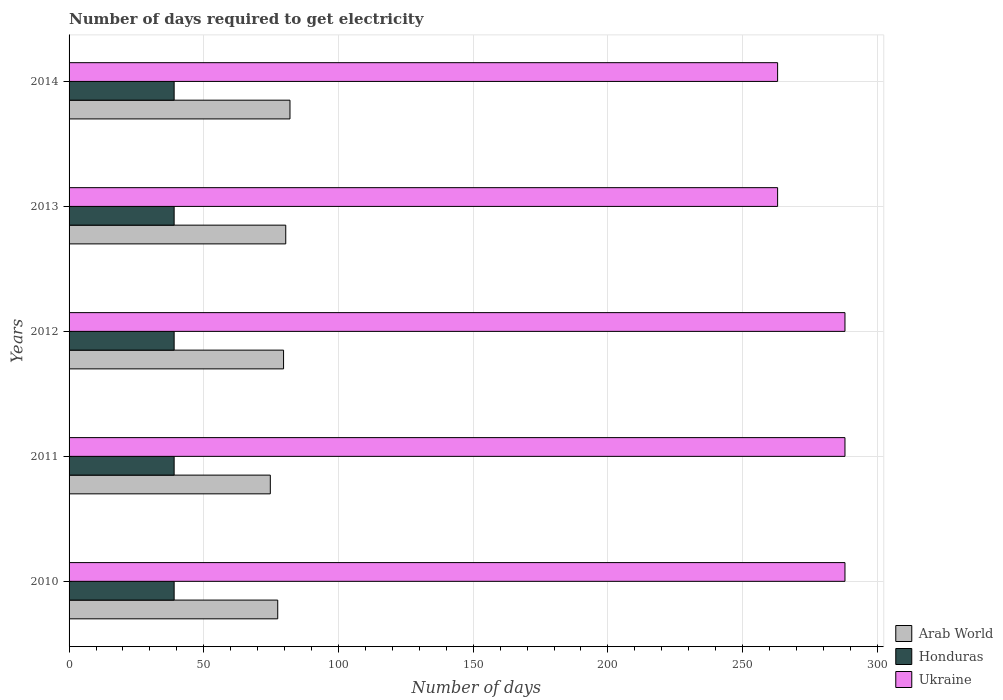Are the number of bars on each tick of the Y-axis equal?
Give a very brief answer. Yes. How many bars are there on the 2nd tick from the top?
Offer a terse response. 3. How many bars are there on the 1st tick from the bottom?
Your response must be concise. 3. What is the label of the 5th group of bars from the top?
Provide a short and direct response. 2010. What is the number of days required to get electricity in in Arab World in 2010?
Offer a terse response. 77.45. Across all years, what is the maximum number of days required to get electricity in in Ukraine?
Make the answer very short. 288. Across all years, what is the minimum number of days required to get electricity in in Honduras?
Ensure brevity in your answer.  39. What is the total number of days required to get electricity in in Ukraine in the graph?
Your answer should be very brief. 1390. What is the difference between the number of days required to get electricity in in Ukraine in 2011 and that in 2014?
Offer a very short reply. 25. What is the difference between the number of days required to get electricity in in Ukraine in 2010 and the number of days required to get electricity in in Honduras in 2012?
Make the answer very short. 249. What is the average number of days required to get electricity in in Ukraine per year?
Provide a short and direct response. 278. In the year 2012, what is the difference between the number of days required to get electricity in in Honduras and number of days required to get electricity in in Ukraine?
Keep it short and to the point. -249. What is the ratio of the number of days required to get electricity in in Arab World in 2011 to that in 2012?
Provide a short and direct response. 0.94. Is the number of days required to get electricity in in Ukraine in 2011 less than that in 2014?
Ensure brevity in your answer.  No. Is the difference between the number of days required to get electricity in in Honduras in 2011 and 2013 greater than the difference between the number of days required to get electricity in in Ukraine in 2011 and 2013?
Ensure brevity in your answer.  No. What is the difference between the highest and the second highest number of days required to get electricity in in Arab World?
Your answer should be very brief. 1.57. What is the difference between the highest and the lowest number of days required to get electricity in in Honduras?
Make the answer very short. 0. What does the 2nd bar from the top in 2011 represents?
Offer a very short reply. Honduras. What does the 2nd bar from the bottom in 2013 represents?
Keep it short and to the point. Honduras. How many bars are there?
Provide a short and direct response. 15. Are all the bars in the graph horizontal?
Your answer should be very brief. Yes. How many years are there in the graph?
Keep it short and to the point. 5. What is the difference between two consecutive major ticks on the X-axis?
Offer a very short reply. 50. Does the graph contain any zero values?
Keep it short and to the point. No. Where does the legend appear in the graph?
Offer a very short reply. Bottom right. How many legend labels are there?
Offer a very short reply. 3. How are the legend labels stacked?
Your answer should be very brief. Vertical. What is the title of the graph?
Give a very brief answer. Number of days required to get electricity. What is the label or title of the X-axis?
Make the answer very short. Number of days. What is the Number of days in Arab World in 2010?
Offer a terse response. 77.45. What is the Number of days of Ukraine in 2010?
Ensure brevity in your answer.  288. What is the Number of days of Arab World in 2011?
Your answer should be very brief. 74.7. What is the Number of days of Honduras in 2011?
Give a very brief answer. 39. What is the Number of days of Ukraine in 2011?
Offer a terse response. 288. What is the Number of days in Arab World in 2012?
Give a very brief answer. 79.62. What is the Number of days of Honduras in 2012?
Your answer should be compact. 39. What is the Number of days of Ukraine in 2012?
Provide a short and direct response. 288. What is the Number of days in Arab World in 2013?
Provide a succinct answer. 80.43. What is the Number of days of Honduras in 2013?
Provide a succinct answer. 39. What is the Number of days in Ukraine in 2013?
Your response must be concise. 263. What is the Number of days of Honduras in 2014?
Keep it short and to the point. 39. What is the Number of days in Ukraine in 2014?
Your answer should be very brief. 263. Across all years, what is the maximum Number of days in Honduras?
Provide a succinct answer. 39. Across all years, what is the maximum Number of days in Ukraine?
Give a very brief answer. 288. Across all years, what is the minimum Number of days of Arab World?
Ensure brevity in your answer.  74.7. Across all years, what is the minimum Number of days of Ukraine?
Make the answer very short. 263. What is the total Number of days of Arab World in the graph?
Provide a succinct answer. 394.2. What is the total Number of days in Honduras in the graph?
Your response must be concise. 195. What is the total Number of days of Ukraine in the graph?
Provide a succinct answer. 1390. What is the difference between the Number of days in Arab World in 2010 and that in 2011?
Provide a succinct answer. 2.75. What is the difference between the Number of days in Arab World in 2010 and that in 2012?
Give a very brief answer. -2.17. What is the difference between the Number of days of Arab World in 2010 and that in 2013?
Provide a succinct answer. -2.98. What is the difference between the Number of days of Ukraine in 2010 and that in 2013?
Ensure brevity in your answer.  25. What is the difference between the Number of days in Arab World in 2010 and that in 2014?
Make the answer very short. -4.55. What is the difference between the Number of days in Honduras in 2010 and that in 2014?
Your answer should be compact. 0. What is the difference between the Number of days in Arab World in 2011 and that in 2012?
Your answer should be compact. -4.92. What is the difference between the Number of days in Ukraine in 2011 and that in 2012?
Offer a very short reply. 0. What is the difference between the Number of days in Arab World in 2011 and that in 2013?
Provide a succinct answer. -5.73. What is the difference between the Number of days in Honduras in 2011 and that in 2013?
Ensure brevity in your answer.  0. What is the difference between the Number of days in Honduras in 2011 and that in 2014?
Give a very brief answer. 0. What is the difference between the Number of days of Arab World in 2012 and that in 2013?
Provide a succinct answer. -0.81. What is the difference between the Number of days of Honduras in 2012 and that in 2013?
Make the answer very short. 0. What is the difference between the Number of days of Arab World in 2012 and that in 2014?
Your answer should be very brief. -2.38. What is the difference between the Number of days in Honduras in 2012 and that in 2014?
Provide a short and direct response. 0. What is the difference between the Number of days of Ukraine in 2012 and that in 2014?
Keep it short and to the point. 25. What is the difference between the Number of days of Arab World in 2013 and that in 2014?
Ensure brevity in your answer.  -1.57. What is the difference between the Number of days in Honduras in 2013 and that in 2014?
Ensure brevity in your answer.  0. What is the difference between the Number of days of Arab World in 2010 and the Number of days of Honduras in 2011?
Ensure brevity in your answer.  38.45. What is the difference between the Number of days of Arab World in 2010 and the Number of days of Ukraine in 2011?
Provide a succinct answer. -210.55. What is the difference between the Number of days of Honduras in 2010 and the Number of days of Ukraine in 2011?
Give a very brief answer. -249. What is the difference between the Number of days of Arab World in 2010 and the Number of days of Honduras in 2012?
Your response must be concise. 38.45. What is the difference between the Number of days of Arab World in 2010 and the Number of days of Ukraine in 2012?
Offer a terse response. -210.55. What is the difference between the Number of days in Honduras in 2010 and the Number of days in Ukraine in 2012?
Ensure brevity in your answer.  -249. What is the difference between the Number of days in Arab World in 2010 and the Number of days in Honduras in 2013?
Your answer should be compact. 38.45. What is the difference between the Number of days in Arab World in 2010 and the Number of days in Ukraine in 2013?
Give a very brief answer. -185.55. What is the difference between the Number of days in Honduras in 2010 and the Number of days in Ukraine in 2013?
Provide a succinct answer. -224. What is the difference between the Number of days in Arab World in 2010 and the Number of days in Honduras in 2014?
Provide a short and direct response. 38.45. What is the difference between the Number of days of Arab World in 2010 and the Number of days of Ukraine in 2014?
Your answer should be very brief. -185.55. What is the difference between the Number of days in Honduras in 2010 and the Number of days in Ukraine in 2014?
Keep it short and to the point. -224. What is the difference between the Number of days of Arab World in 2011 and the Number of days of Honduras in 2012?
Ensure brevity in your answer.  35.7. What is the difference between the Number of days of Arab World in 2011 and the Number of days of Ukraine in 2012?
Your answer should be compact. -213.3. What is the difference between the Number of days of Honduras in 2011 and the Number of days of Ukraine in 2012?
Provide a short and direct response. -249. What is the difference between the Number of days of Arab World in 2011 and the Number of days of Honduras in 2013?
Give a very brief answer. 35.7. What is the difference between the Number of days in Arab World in 2011 and the Number of days in Ukraine in 2013?
Your answer should be very brief. -188.3. What is the difference between the Number of days of Honduras in 2011 and the Number of days of Ukraine in 2013?
Ensure brevity in your answer.  -224. What is the difference between the Number of days in Arab World in 2011 and the Number of days in Honduras in 2014?
Your answer should be very brief. 35.7. What is the difference between the Number of days of Arab World in 2011 and the Number of days of Ukraine in 2014?
Ensure brevity in your answer.  -188.3. What is the difference between the Number of days in Honduras in 2011 and the Number of days in Ukraine in 2014?
Ensure brevity in your answer.  -224. What is the difference between the Number of days of Arab World in 2012 and the Number of days of Honduras in 2013?
Make the answer very short. 40.62. What is the difference between the Number of days of Arab World in 2012 and the Number of days of Ukraine in 2013?
Ensure brevity in your answer.  -183.38. What is the difference between the Number of days of Honduras in 2012 and the Number of days of Ukraine in 2013?
Make the answer very short. -224. What is the difference between the Number of days in Arab World in 2012 and the Number of days in Honduras in 2014?
Provide a succinct answer. 40.62. What is the difference between the Number of days in Arab World in 2012 and the Number of days in Ukraine in 2014?
Offer a terse response. -183.38. What is the difference between the Number of days of Honduras in 2012 and the Number of days of Ukraine in 2014?
Make the answer very short. -224. What is the difference between the Number of days in Arab World in 2013 and the Number of days in Honduras in 2014?
Offer a very short reply. 41.43. What is the difference between the Number of days of Arab World in 2013 and the Number of days of Ukraine in 2014?
Provide a succinct answer. -182.57. What is the difference between the Number of days of Honduras in 2013 and the Number of days of Ukraine in 2014?
Your answer should be compact. -224. What is the average Number of days in Arab World per year?
Keep it short and to the point. 78.84. What is the average Number of days of Honduras per year?
Give a very brief answer. 39. What is the average Number of days in Ukraine per year?
Ensure brevity in your answer.  278. In the year 2010, what is the difference between the Number of days of Arab World and Number of days of Honduras?
Offer a terse response. 38.45. In the year 2010, what is the difference between the Number of days in Arab World and Number of days in Ukraine?
Ensure brevity in your answer.  -210.55. In the year 2010, what is the difference between the Number of days in Honduras and Number of days in Ukraine?
Keep it short and to the point. -249. In the year 2011, what is the difference between the Number of days of Arab World and Number of days of Honduras?
Make the answer very short. 35.7. In the year 2011, what is the difference between the Number of days of Arab World and Number of days of Ukraine?
Provide a short and direct response. -213.3. In the year 2011, what is the difference between the Number of days in Honduras and Number of days in Ukraine?
Your answer should be compact. -249. In the year 2012, what is the difference between the Number of days of Arab World and Number of days of Honduras?
Ensure brevity in your answer.  40.62. In the year 2012, what is the difference between the Number of days of Arab World and Number of days of Ukraine?
Ensure brevity in your answer.  -208.38. In the year 2012, what is the difference between the Number of days of Honduras and Number of days of Ukraine?
Make the answer very short. -249. In the year 2013, what is the difference between the Number of days of Arab World and Number of days of Honduras?
Make the answer very short. 41.43. In the year 2013, what is the difference between the Number of days in Arab World and Number of days in Ukraine?
Your answer should be very brief. -182.57. In the year 2013, what is the difference between the Number of days of Honduras and Number of days of Ukraine?
Provide a short and direct response. -224. In the year 2014, what is the difference between the Number of days of Arab World and Number of days of Honduras?
Ensure brevity in your answer.  43. In the year 2014, what is the difference between the Number of days of Arab World and Number of days of Ukraine?
Your answer should be compact. -181. In the year 2014, what is the difference between the Number of days of Honduras and Number of days of Ukraine?
Provide a short and direct response. -224. What is the ratio of the Number of days in Arab World in 2010 to that in 2011?
Provide a succinct answer. 1.04. What is the ratio of the Number of days of Ukraine in 2010 to that in 2011?
Ensure brevity in your answer.  1. What is the ratio of the Number of days in Arab World in 2010 to that in 2012?
Offer a terse response. 0.97. What is the ratio of the Number of days of Ukraine in 2010 to that in 2012?
Keep it short and to the point. 1. What is the ratio of the Number of days in Ukraine in 2010 to that in 2013?
Offer a very short reply. 1.1. What is the ratio of the Number of days of Arab World in 2010 to that in 2014?
Ensure brevity in your answer.  0.94. What is the ratio of the Number of days in Honduras in 2010 to that in 2014?
Offer a very short reply. 1. What is the ratio of the Number of days of Ukraine in 2010 to that in 2014?
Offer a very short reply. 1.1. What is the ratio of the Number of days of Arab World in 2011 to that in 2012?
Provide a succinct answer. 0.94. What is the ratio of the Number of days of Arab World in 2011 to that in 2013?
Make the answer very short. 0.93. What is the ratio of the Number of days of Honduras in 2011 to that in 2013?
Your response must be concise. 1. What is the ratio of the Number of days in Ukraine in 2011 to that in 2013?
Provide a short and direct response. 1.1. What is the ratio of the Number of days in Arab World in 2011 to that in 2014?
Make the answer very short. 0.91. What is the ratio of the Number of days of Honduras in 2011 to that in 2014?
Offer a very short reply. 1. What is the ratio of the Number of days in Ukraine in 2011 to that in 2014?
Your answer should be very brief. 1.1. What is the ratio of the Number of days in Arab World in 2012 to that in 2013?
Provide a succinct answer. 0.99. What is the ratio of the Number of days in Honduras in 2012 to that in 2013?
Give a very brief answer. 1. What is the ratio of the Number of days in Ukraine in 2012 to that in 2013?
Your answer should be compact. 1.1. What is the ratio of the Number of days of Ukraine in 2012 to that in 2014?
Your response must be concise. 1.1. What is the ratio of the Number of days of Arab World in 2013 to that in 2014?
Keep it short and to the point. 0.98. What is the ratio of the Number of days in Honduras in 2013 to that in 2014?
Your response must be concise. 1. What is the difference between the highest and the second highest Number of days of Arab World?
Your response must be concise. 1.57. What is the difference between the highest and the second highest Number of days of Honduras?
Your answer should be compact. 0. What is the difference between the highest and the lowest Number of days of Honduras?
Give a very brief answer. 0. 